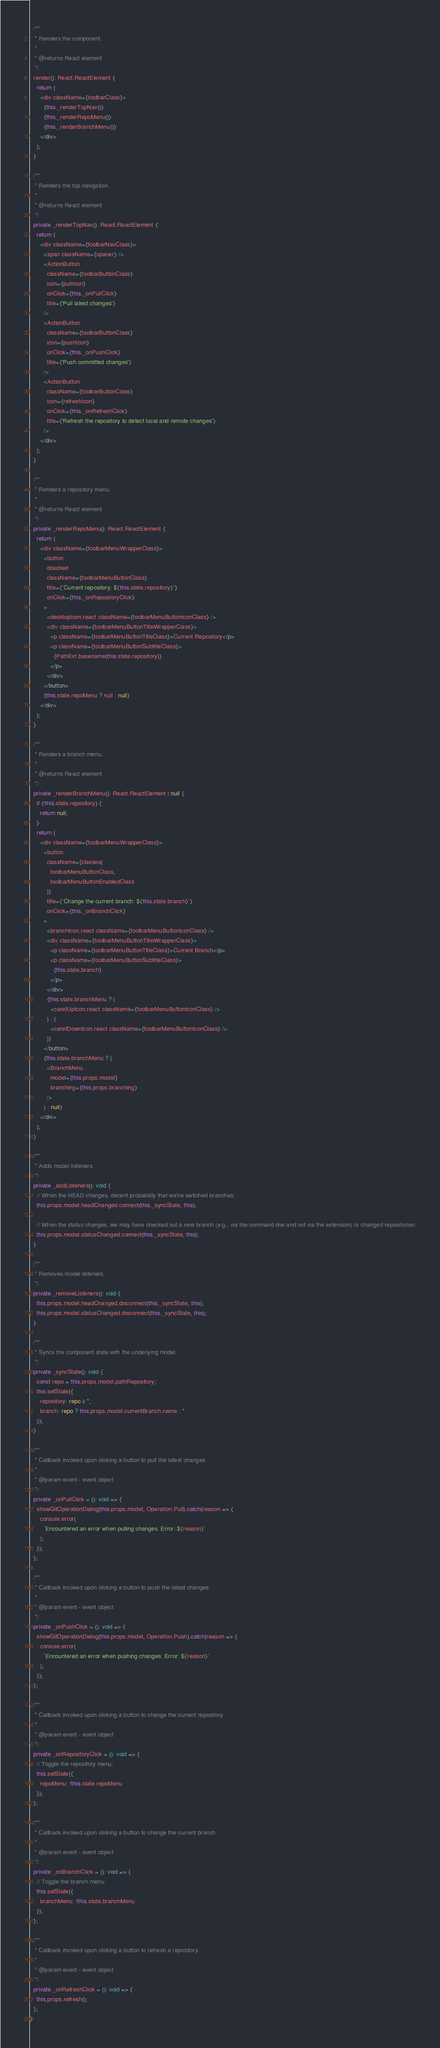<code> <loc_0><loc_0><loc_500><loc_500><_TypeScript_>
  /**
   * Renders the component.
   *
   * @returns React element
   */
  render(): React.ReactElement {
    return (
      <div className={toolbarClass}>
        {this._renderTopNav()}
        {this._renderRepoMenu()}
        {this._renderBranchMenu()}
      </div>
    );
  }

  /**
   * Renders the top navigation.
   *
   * @returns React element
   */
  private _renderTopNav(): React.ReactElement {
    return (
      <div className={toolbarNavClass}>
        <span className={spacer} />
        <ActionButton
          className={toolbarButtonClass}
          icon={pullIcon}
          onClick={this._onPullClick}
          title={'Pull latest changes'}
        />
        <ActionButton
          className={toolbarButtonClass}
          icon={pushIcon}
          onClick={this._onPushClick}
          title={'Push committed changes'}
        />
        <ActionButton
          className={toolbarButtonClass}
          icon={refreshIcon}
          onClick={this._onRefreshClick}
          title={'Refresh the repository to detect local and remote changes'}
        />
      </div>
    );
  }

  /**
   * Renders a repository menu.
   *
   * @returns React element
   */
  private _renderRepoMenu(): React.ReactElement {
    return (
      <div className={toolbarMenuWrapperClass}>
        <button
          disabled
          className={toolbarMenuButtonClass}
          title={`Current repository: ${this.state.repository}`}
          onClick={this._onRepositoryClick}
        >
          <desktopIcon.react className={toolbarMenuButtonIconClass} />
          <div className={toolbarMenuButtonTitleWrapperClass}>
            <p className={toolbarMenuButtonTitleClass}>Current Repository</p>
            <p className={toolbarMenuButtonSubtitleClass}>
              {PathExt.basename(this.state.repository)}
            </p>
          </div>
        </button>
        {this.state.repoMenu ? null : null}
      </div>
    );
  }

  /**
   * Renders a branch menu.
   *
   * @returns React element
   */
  private _renderBranchMenu(): React.ReactElement | null {
    if (!this.state.repository) {
      return null;
    }
    return (
      <div className={toolbarMenuWrapperClass}>
        <button
          className={classes(
            toolbarMenuButtonClass,
            toolbarMenuButtonEnabledClass
          )}
          title={`Change the current branch: ${this.state.branch}`}
          onClick={this._onBranchClick}
        >
          <branchIcon.react className={toolbarMenuButtonIconClass} />
          <div className={toolbarMenuButtonTitleWrapperClass}>
            <p className={toolbarMenuButtonTitleClass}>Current Branch</p>
            <p className={toolbarMenuButtonSubtitleClass}>
              {this.state.branch}
            </p>
          </div>
          {this.state.branchMenu ? (
            <caretUpIcon.react className={toolbarMenuButtonIconClass} />
          ) : (
            <caretDownIcon.react className={toolbarMenuButtonIconClass} />
          )}
        </button>
        {this.state.branchMenu ? (
          <BranchMenu
            model={this.props.model}
            branching={this.props.branching}
          />
        ) : null}
      </div>
    );
  }

  /**
   * Adds model listeners.
   */
  private _addListeners(): void {
    // When the HEAD changes, decent probability that we've switched branches:
    this.props.model.headChanged.connect(this._syncState, this);

    // When the status changes, we may have checked out a new branch (e.g., via the command-line and not via the extension) or changed repositories:
    this.props.model.statusChanged.connect(this._syncState, this);
  }

  /**
   * Removes model listeners.
   */
  private _removeListeners(): void {
    this.props.model.headChanged.disconnect(this._syncState, this);
    this.props.model.statusChanged.disconnect(this._syncState, this);
  }

  /**
   * Syncs the component state with the underlying model.
   */
  private _syncState(): void {
    const repo = this.props.model.pathRepository;
    this.setState({
      repository: repo || '',
      branch: repo ? this.props.model.currentBranch.name : ''
    });
  }

  /**
   * Callback invoked upon clicking a button to pull the latest changes.
   *
   * @param event - event object
   */
  private _onPullClick = (): void => {
    showGitOperationDialog(this.props.model, Operation.Pull).catch(reason => {
      console.error(
        `Encountered an error when pulling changes. Error: ${reason}`
      );
    });
  };

  /**
   * Callback invoked upon clicking a button to push the latest changes.
   *
   * @param event - event object
   */
  private _onPushClick = (): void => {
    showGitOperationDialog(this.props.model, Operation.Push).catch(reason => {
      console.error(
        `Encountered an error when pushing changes. Error: ${reason}`
      );
    });
  };

  /**
   * Callback invoked upon clicking a button to change the current repository.
   *
   * @param event - event object
   */
  private _onRepositoryClick = (): void => {
    // Toggle the repository menu:
    this.setState({
      repoMenu: !this.state.repoMenu
    });
  };

  /**
   * Callback invoked upon clicking a button to change the current branch.
   *
   * @param event - event object
   */
  private _onBranchClick = (): void => {
    // Toggle the branch menu:
    this.setState({
      branchMenu: !this.state.branchMenu
    });
  };

  /**
   * Callback invoked upon clicking a button to refresh a repository.
   *
   * @param event - event object
   */
  private _onRefreshClick = (): void => {
    this.props.refresh();
  };
}
</code> 